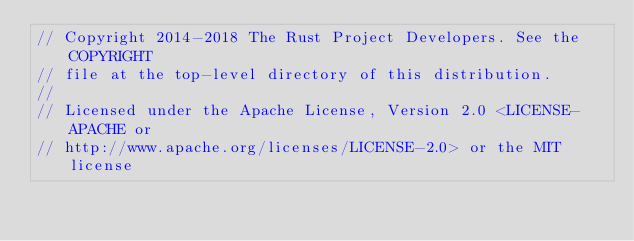<code> <loc_0><loc_0><loc_500><loc_500><_Rust_>// Copyright 2014-2018 The Rust Project Developers. See the COPYRIGHT
// file at the top-level directory of this distribution.
//
// Licensed under the Apache License, Version 2.0 <LICENSE-APACHE or
// http://www.apache.org/licenses/LICENSE-2.0> or the MIT license</code> 